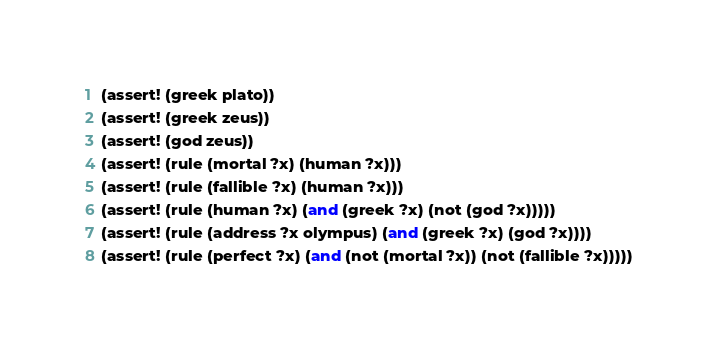<code> <loc_0><loc_0><loc_500><loc_500><_Scheme_>(assert! (greek plato))
(assert! (greek zeus))
(assert! (god zeus))
(assert! (rule (mortal ?x) (human ?x)))
(assert! (rule (fallible ?x) (human ?x)))
(assert! (rule (human ?x) (and (greek ?x) (not (god ?x)))))
(assert! (rule (address ?x olympus) (and (greek ?x) (god ?x))))
(assert! (rule (perfect ?x) (and (not (mortal ?x)) (not (fallible ?x)))))
</code> 